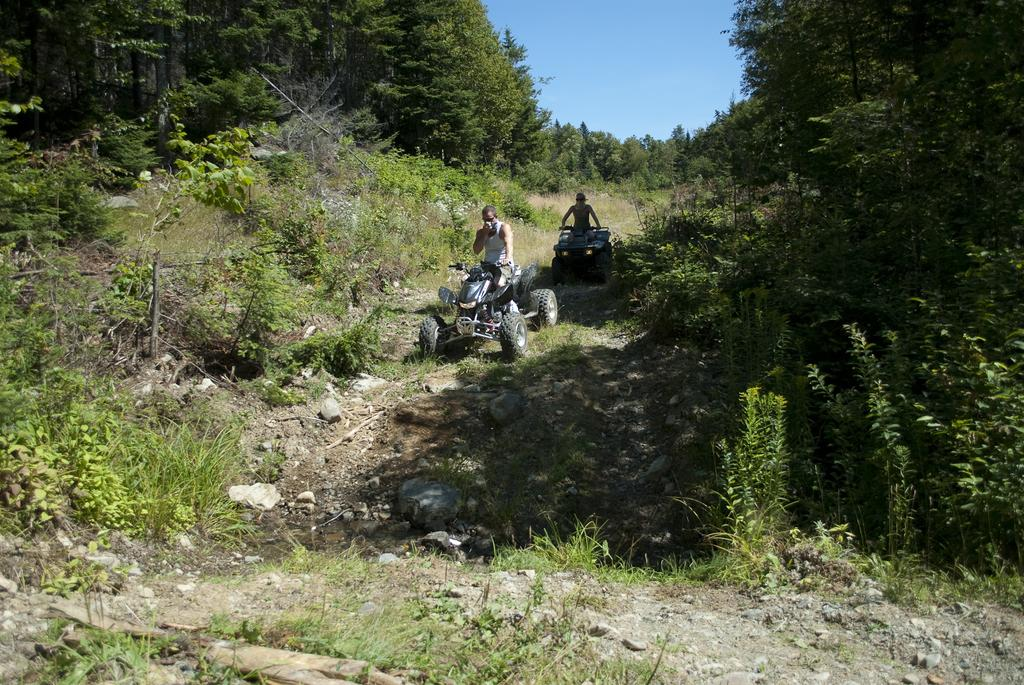What are the two persons in the image doing? The two persons are sitting in vehicles in the center of the image. What can be seen in the background of the image? There is sky, trees, plants, and grass visible in the background of the image. What type of cheese is being served at the start of the downtown event in the image? There is no cheese, downtown event, or start of an event present in the image. 